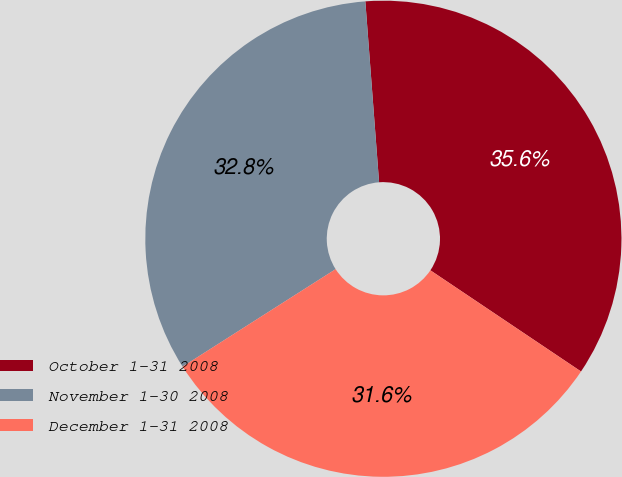Convert chart. <chart><loc_0><loc_0><loc_500><loc_500><pie_chart><fcel>October 1-31 2008<fcel>November 1-30 2008<fcel>December 1-31 2008<nl><fcel>35.62%<fcel>32.82%<fcel>31.56%<nl></chart> 